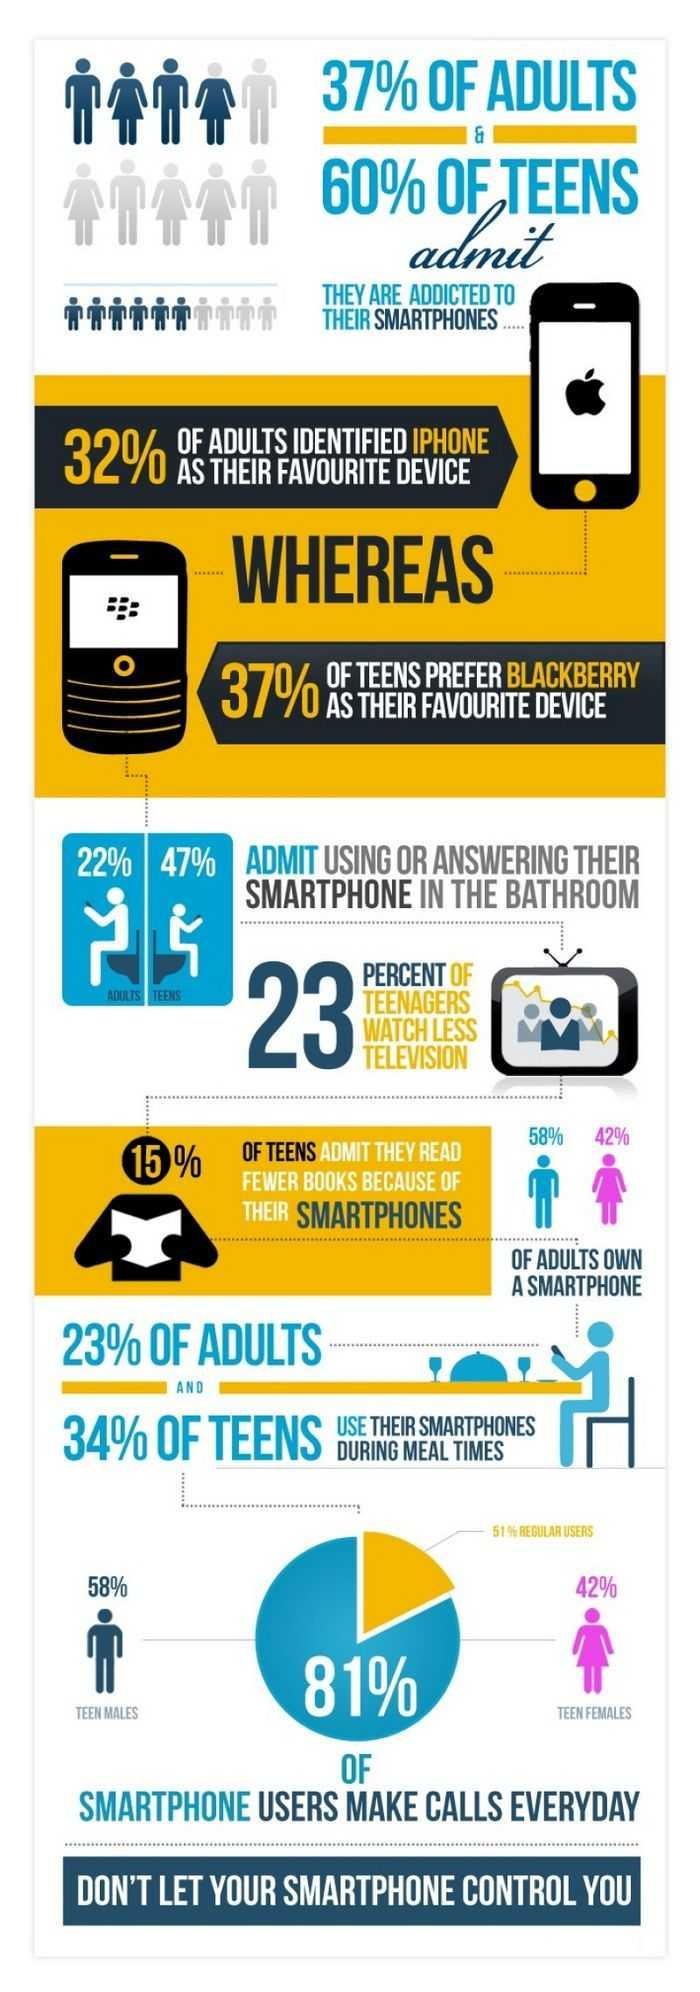Identify some key points in this picture. Teenagers are more likely to use their smartphones or answer them while in the bathroom than adults. According to a recent study, 81% of teenagers use their smartphones to make calls every day, and of that percentage, 42% are female. In recent times, a significant percentage of adults, approximately 23%, have been observed to use their smartphones during meal times. The Blackberry is the preferred mobile device among teenagers. According to a survey, 15% of teens read fewer books due to their excessive use of smartphones. 